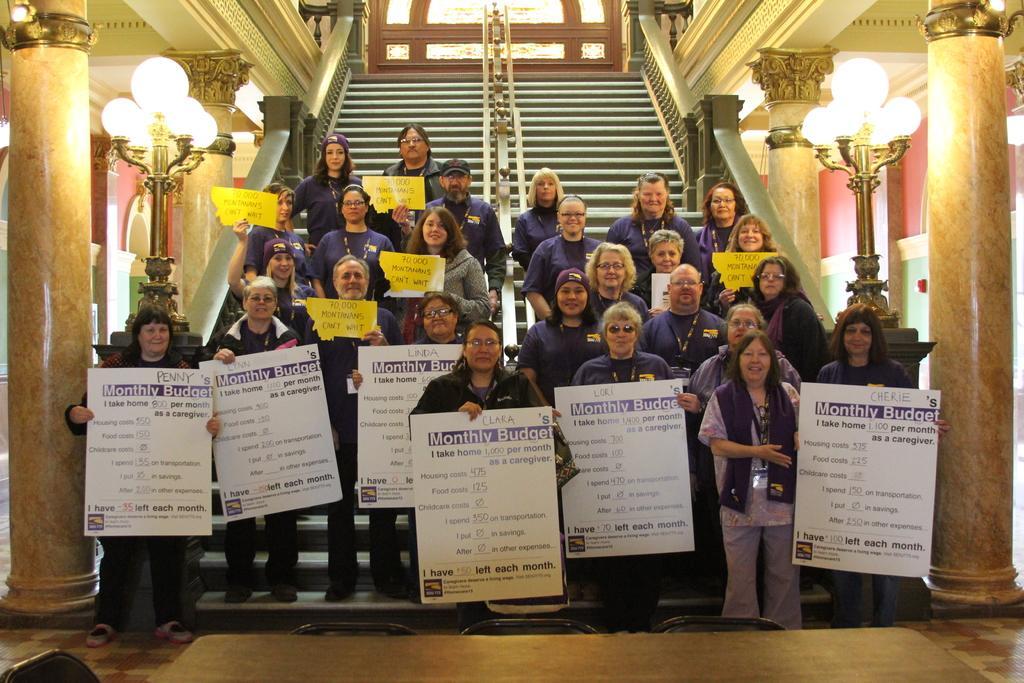In one or two sentences, can you explain what this image depicts? In this image we can see the people standing on the stairs and holding the text boards. We can also see a few people holding the text papers and we can see the people standing on the floor and holding the boards. At the bottom we can see a table with the chairs. We can also see the pillars, wall, lights and also the ceiling and the window. 